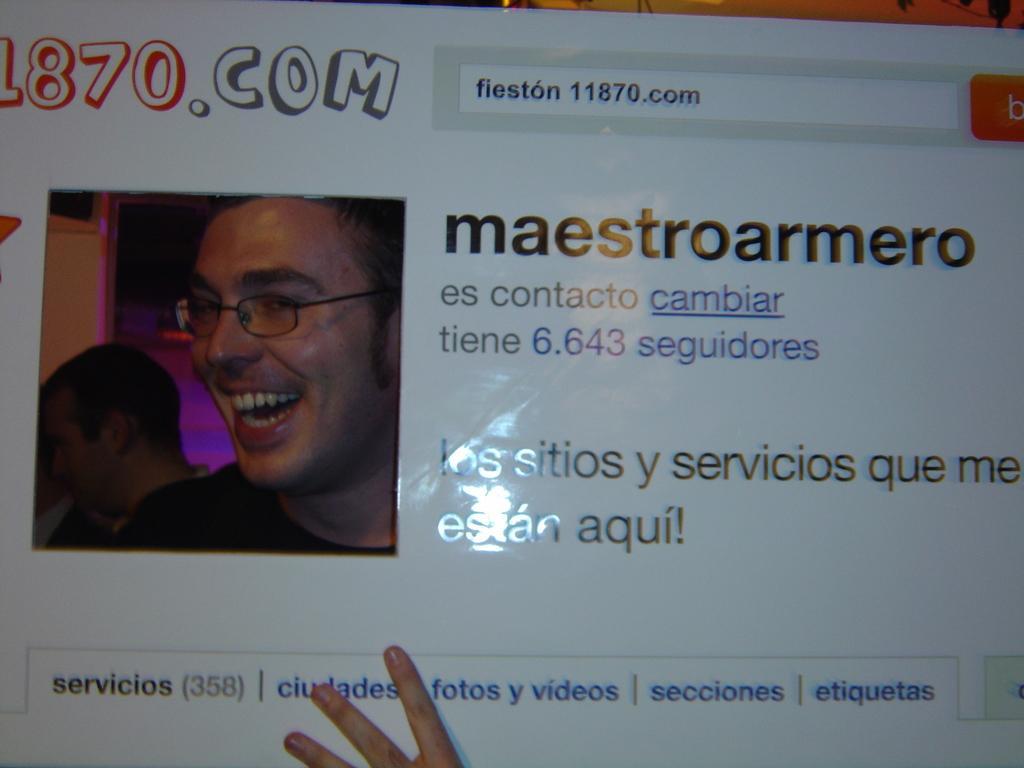Can you describe this image briefly? In the image in the center we can see one board. On the board,we can see one person smiling and we can see something written on it. In the bottom of the image,we can see one human hand. 